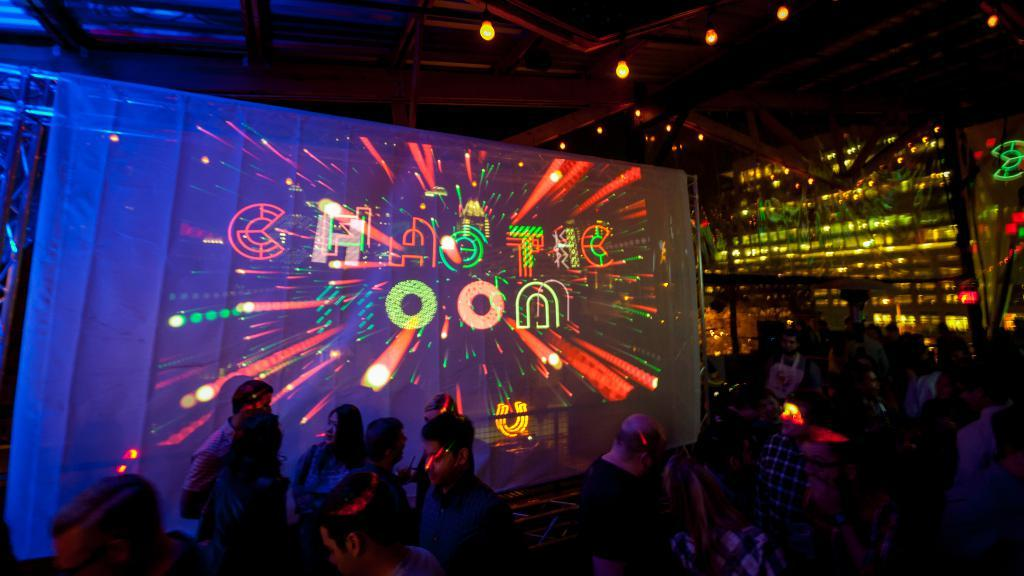Provide a one-sentence caption for the provided image. People are at a night club partying with a giant projected sign that says Chaotic Moon. 